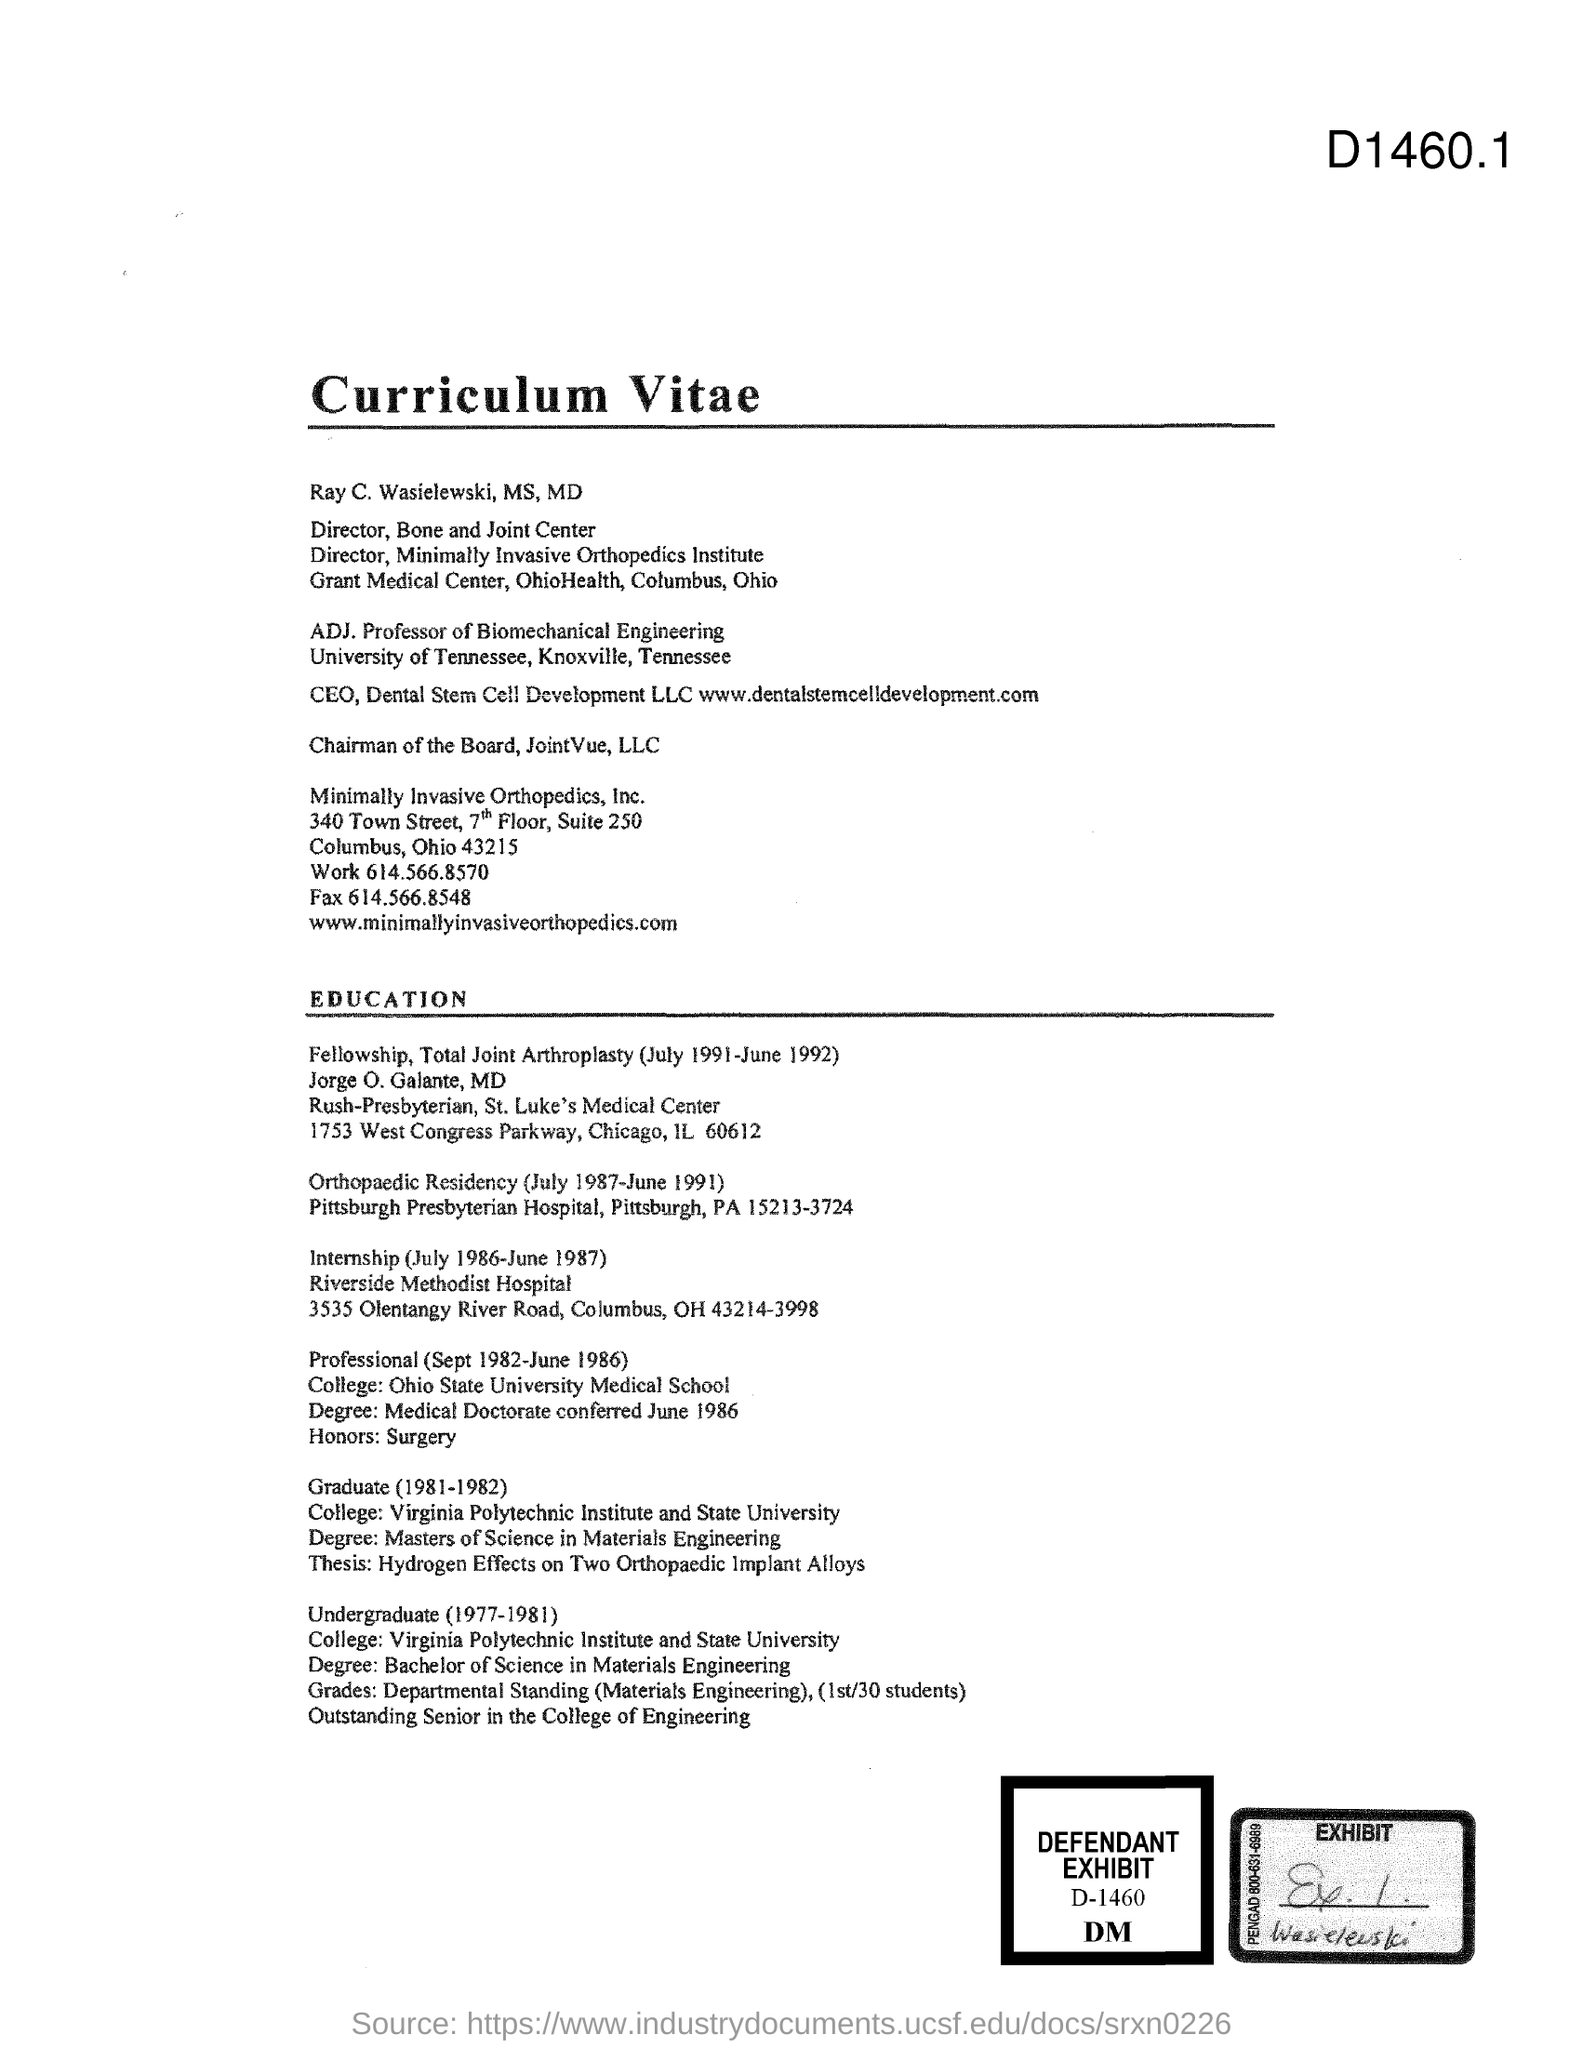Point out several critical features in this image. The document's title is "Curriculum Vitae. 